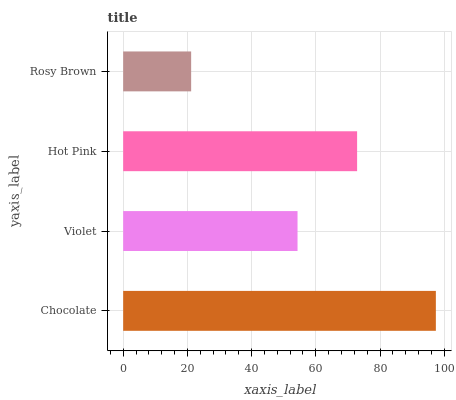Is Rosy Brown the minimum?
Answer yes or no. Yes. Is Chocolate the maximum?
Answer yes or no. Yes. Is Violet the minimum?
Answer yes or no. No. Is Violet the maximum?
Answer yes or no. No. Is Chocolate greater than Violet?
Answer yes or no. Yes. Is Violet less than Chocolate?
Answer yes or no. Yes. Is Violet greater than Chocolate?
Answer yes or no. No. Is Chocolate less than Violet?
Answer yes or no. No. Is Hot Pink the high median?
Answer yes or no. Yes. Is Violet the low median?
Answer yes or no. Yes. Is Rosy Brown the high median?
Answer yes or no. No. Is Chocolate the low median?
Answer yes or no. No. 